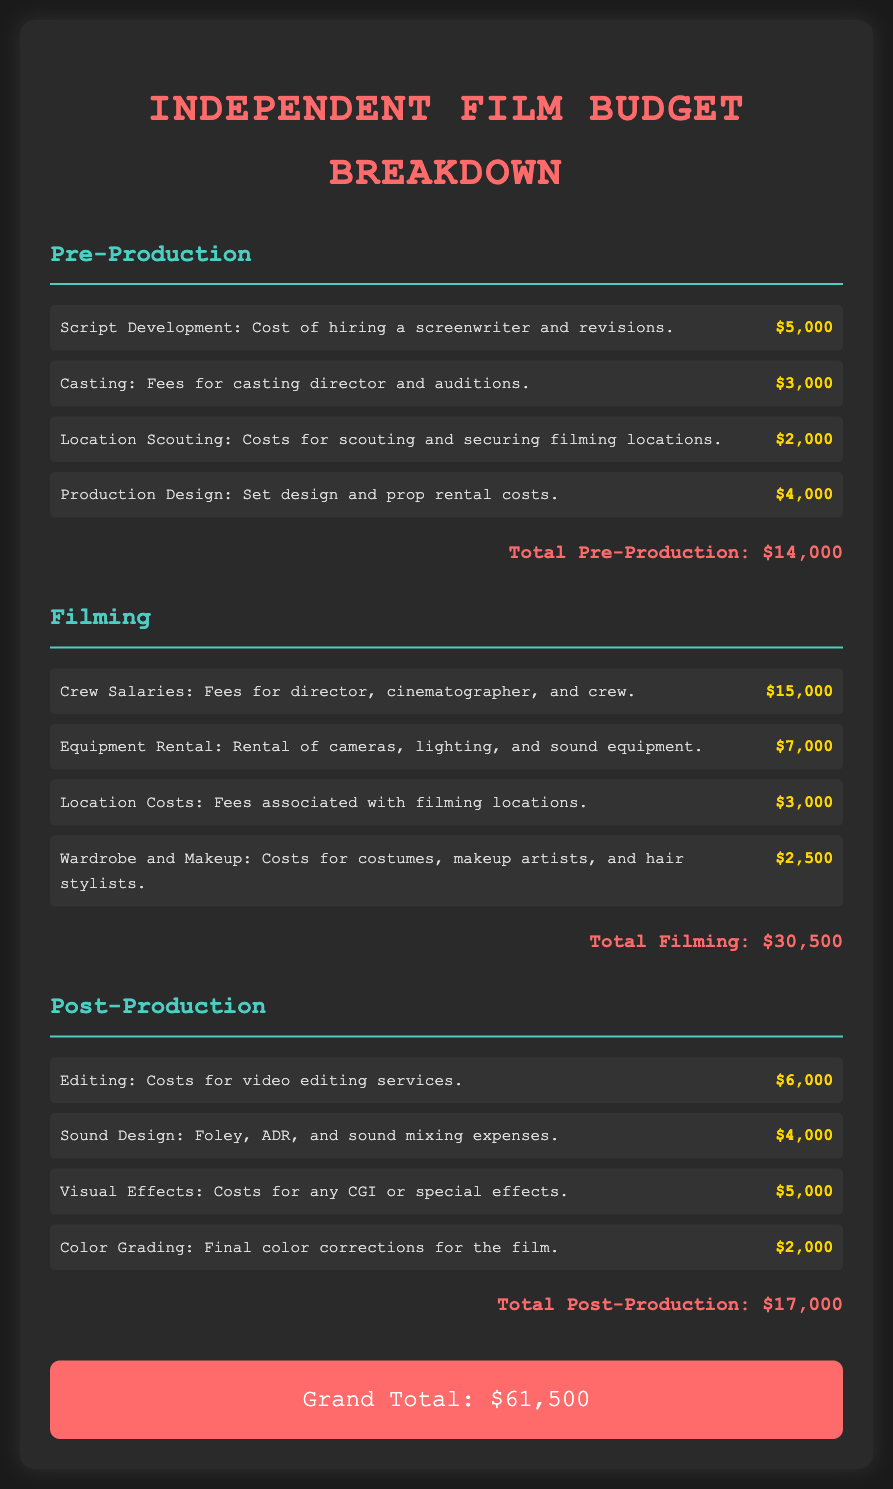What is the total amount allocated for pre-production? The total amount for pre-production is listed at the end of the pre-production section, which is $14,000.
Answer: $14,000 How much does the crew salaries cost? The cost for crew salaries is detailed in the filming section, which notes it as $15,000.
Answer: $15,000 What are the location scouting costs? Location scouting costs are specified in the pre-production section, tagged at $2,000.
Answer: $2,000 What is the cost for sound design? The sound design cost is outlined in the post-production section, labeled as $4,000.
Answer: $4,000 What is the total budget for filming and post-production combined? To find this total, one sums the filming cost ($30,500) and the post-production cost ($17,000), resulting in $47,500.
Answer: $47,500 Which section has the highest total cost? By comparing the total costs from each section, it is clear the filming section has the highest total at $30,500.
Answer: Filming How much is allocated for color grading? The amount allocated for color grading is found in the post-production section and is stated as $2,000.
Answer: $2,000 What is the grand total of the film budget? The grand total is presented at the end of the document as the sum of all sections, which is $61,500.
Answer: $61,500 Which expense in pre-production has the lowest cost? The expense with the lowest cost in the pre-production section is casting at $3,000.
Answer: Casting 